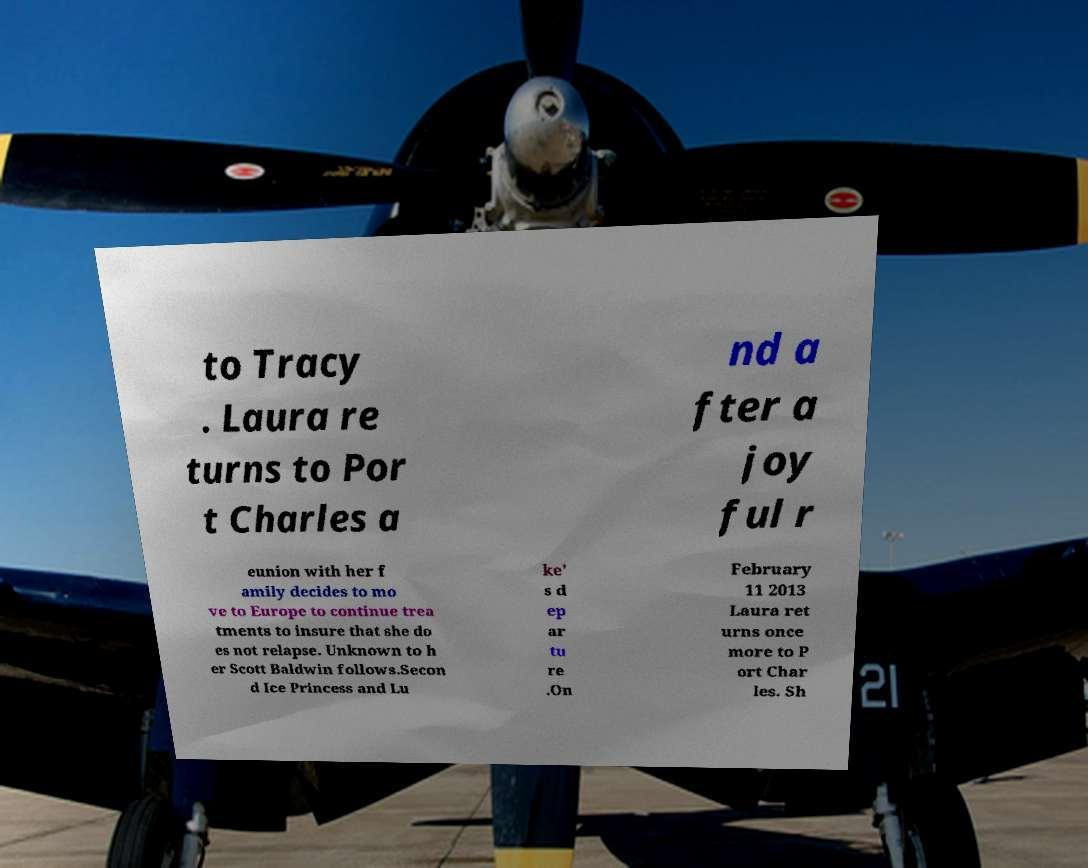Please read and relay the text visible in this image. What does it say? to Tracy . Laura re turns to Por t Charles a nd a fter a joy ful r eunion with her f amily decides to mo ve to Europe to continue trea tments to insure that she do es not relapse. Unknown to h er Scott Baldwin follows.Secon d Ice Princess and Lu ke' s d ep ar tu re .On February 11 2013 Laura ret urns once more to P ort Char les. Sh 